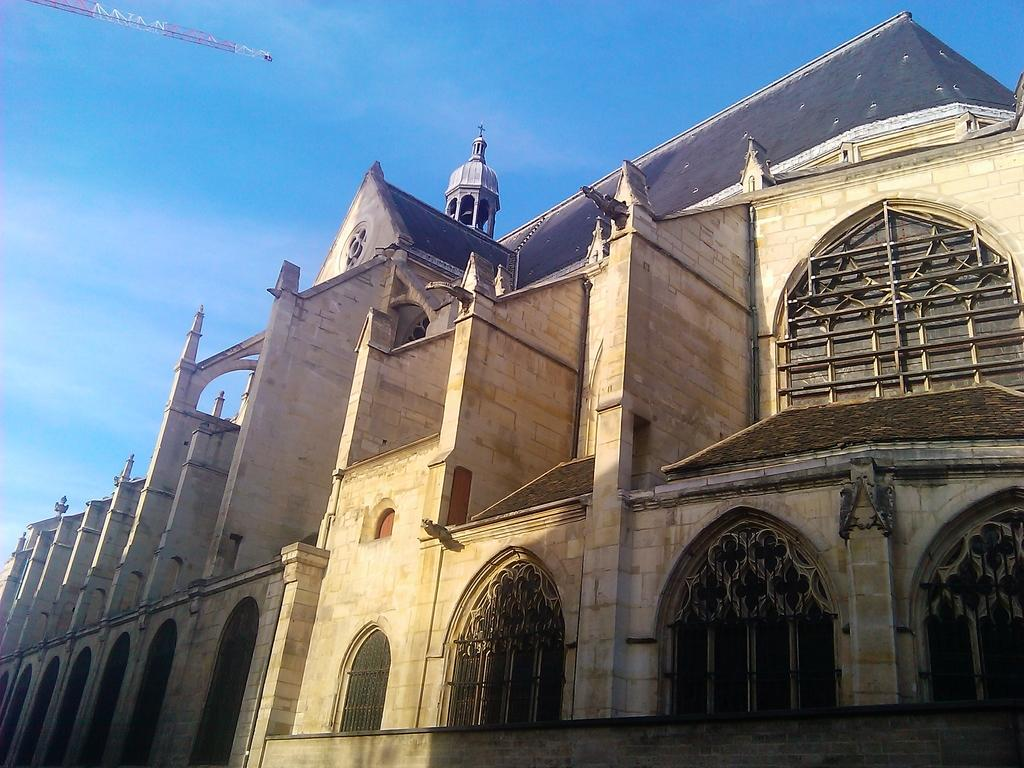What is the main subject of the image? The main subject of the image is a building. What specific features can be observed on the building? The building has windows. What can be seen in the background of the image? The sky is visible in the background of the image. What type of meat is being cooked in the image? There is no meat or cooking activity present in the image; it features a building with windows and a visible sky in the background. 